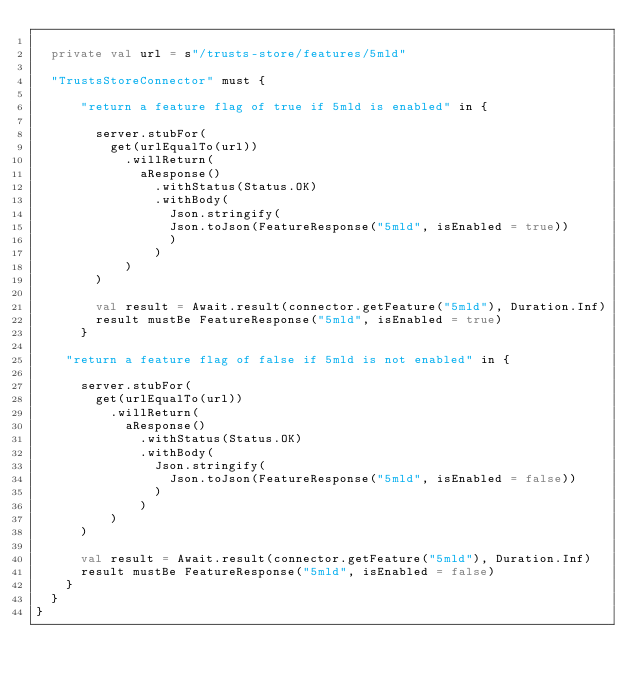<code> <loc_0><loc_0><loc_500><loc_500><_Scala_>
  private val url = s"/trusts-store/features/5mld"

  "TrustsStoreConnector" must {

      "return a feature flag of true if 5mld is enabled" in {

        server.stubFor(
          get(urlEqualTo(url))
            .willReturn(
              aResponse()
                .withStatus(Status.OK)
                .withBody(
                  Json.stringify(
                  Json.toJson(FeatureResponse("5mld", isEnabled = true))
                  )
                )
            )
        )

        val result = Await.result(connector.getFeature("5mld"), Duration.Inf)
        result mustBe FeatureResponse("5mld", isEnabled = true)
      }

    "return a feature flag of false if 5mld is not enabled" in {

      server.stubFor(
        get(urlEqualTo(url))
          .willReturn(
            aResponse()
              .withStatus(Status.OK)
              .withBody(
                Json.stringify(
                  Json.toJson(FeatureResponse("5mld", isEnabled = false))
                )
              )
          )
      )

      val result = Await.result(connector.getFeature("5mld"), Duration.Inf)
      result mustBe FeatureResponse("5mld", isEnabled = false)
    }
  }
}
</code> 